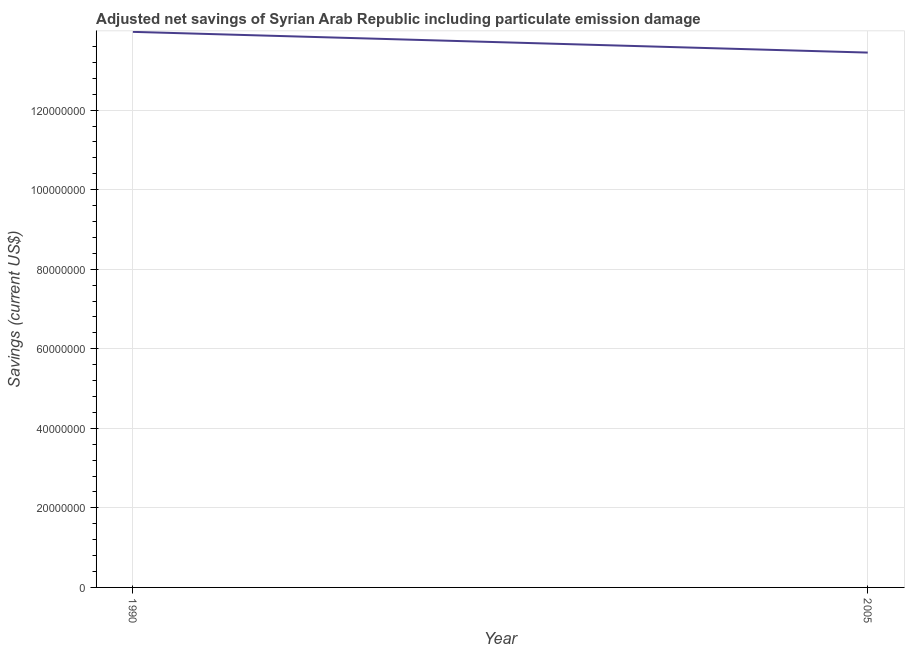What is the adjusted net savings in 1990?
Your answer should be compact. 1.40e+08. Across all years, what is the maximum adjusted net savings?
Your response must be concise. 1.40e+08. Across all years, what is the minimum adjusted net savings?
Keep it short and to the point. 1.34e+08. What is the sum of the adjusted net savings?
Your answer should be compact. 2.74e+08. What is the difference between the adjusted net savings in 1990 and 2005?
Make the answer very short. 5.21e+06. What is the average adjusted net savings per year?
Make the answer very short. 1.37e+08. What is the median adjusted net savings?
Make the answer very short. 1.37e+08. In how many years, is the adjusted net savings greater than 68000000 US$?
Your answer should be compact. 2. Do a majority of the years between 1990 and 2005 (inclusive) have adjusted net savings greater than 128000000 US$?
Your response must be concise. Yes. What is the ratio of the adjusted net savings in 1990 to that in 2005?
Offer a terse response. 1.04. Is the adjusted net savings in 1990 less than that in 2005?
Offer a very short reply. No. In how many years, is the adjusted net savings greater than the average adjusted net savings taken over all years?
Provide a succinct answer. 1. How many lines are there?
Your answer should be very brief. 1. How many years are there in the graph?
Provide a short and direct response. 2. Are the values on the major ticks of Y-axis written in scientific E-notation?
Provide a short and direct response. No. Does the graph contain any zero values?
Provide a succinct answer. No. What is the title of the graph?
Your answer should be very brief. Adjusted net savings of Syrian Arab Republic including particulate emission damage. What is the label or title of the Y-axis?
Keep it short and to the point. Savings (current US$). What is the Savings (current US$) of 1990?
Offer a very short reply. 1.40e+08. What is the Savings (current US$) of 2005?
Provide a short and direct response. 1.34e+08. What is the difference between the Savings (current US$) in 1990 and 2005?
Provide a succinct answer. 5.21e+06. What is the ratio of the Savings (current US$) in 1990 to that in 2005?
Ensure brevity in your answer.  1.04. 